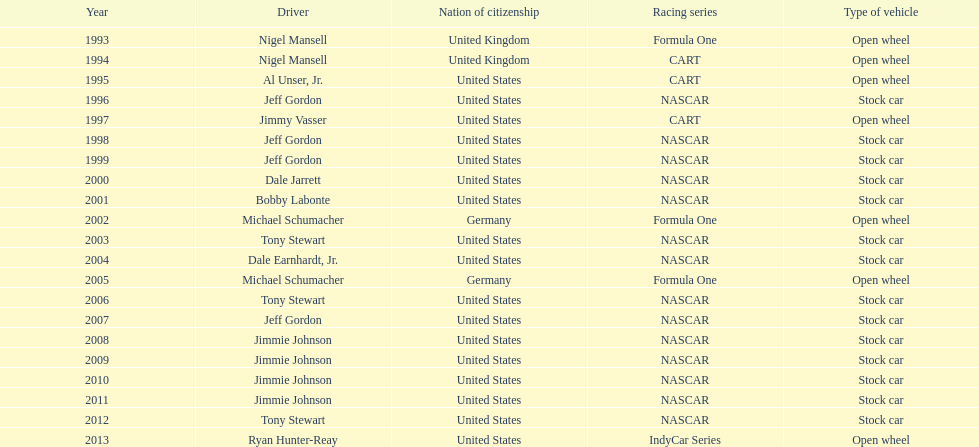From the drivers: nigel mansell, al unser, jr., michael schumacher, and jeff gordon, everyone except one has over one espy award. who possesses only one espy award? Al Unser, Jr. 